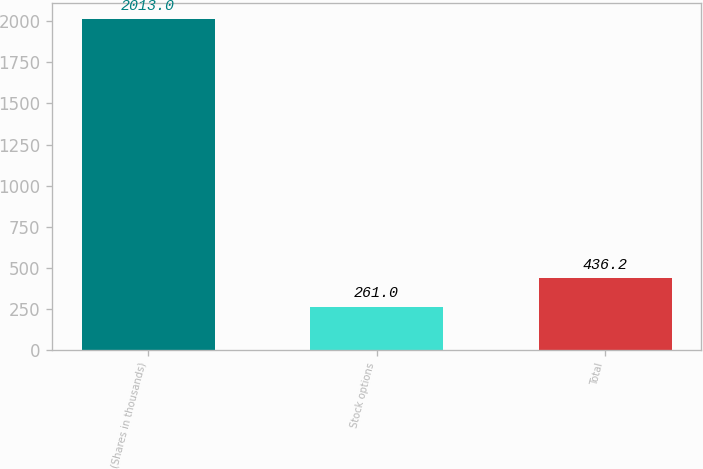Convert chart to OTSL. <chart><loc_0><loc_0><loc_500><loc_500><bar_chart><fcel>(Shares in thousands)<fcel>Stock options<fcel>Total<nl><fcel>2013<fcel>261<fcel>436.2<nl></chart> 